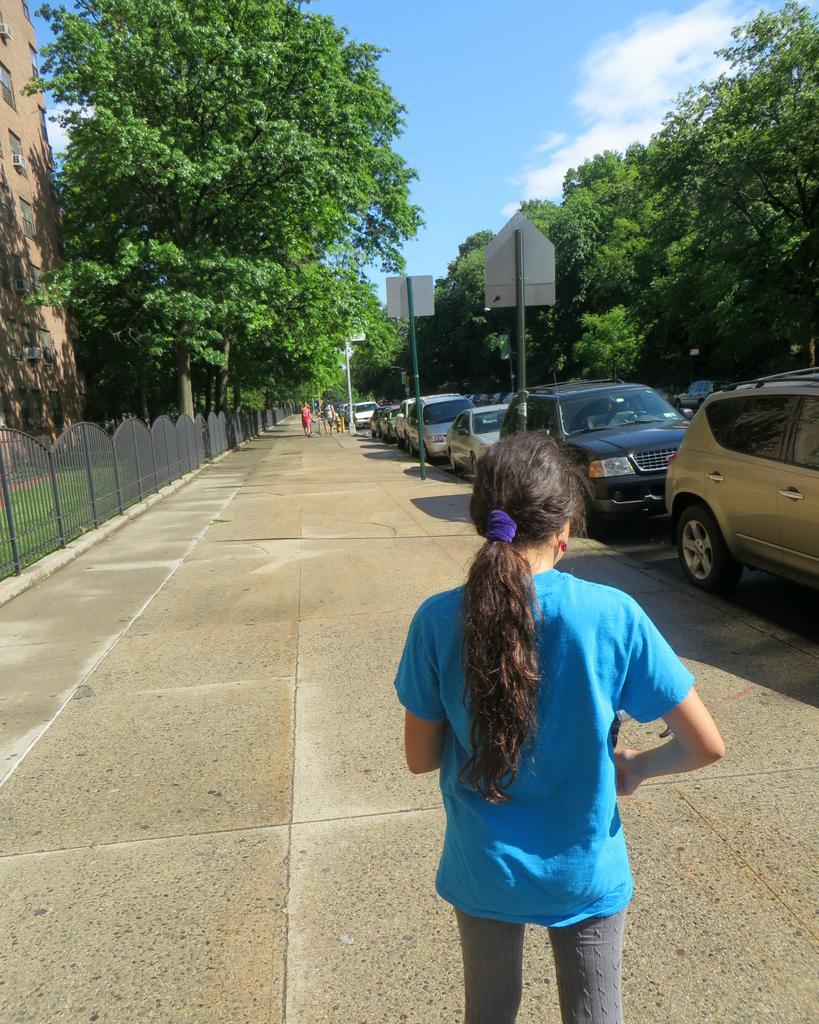Could you give a brief overview of what you see in this image? In this image, there is an outside view. There is a person at the bottom of the image wearing clothes and standing on the footpath. There are some vehicles on the right side of the image. There are trees in the top left and in the top right of the image. There is a sky at the top of the image. 